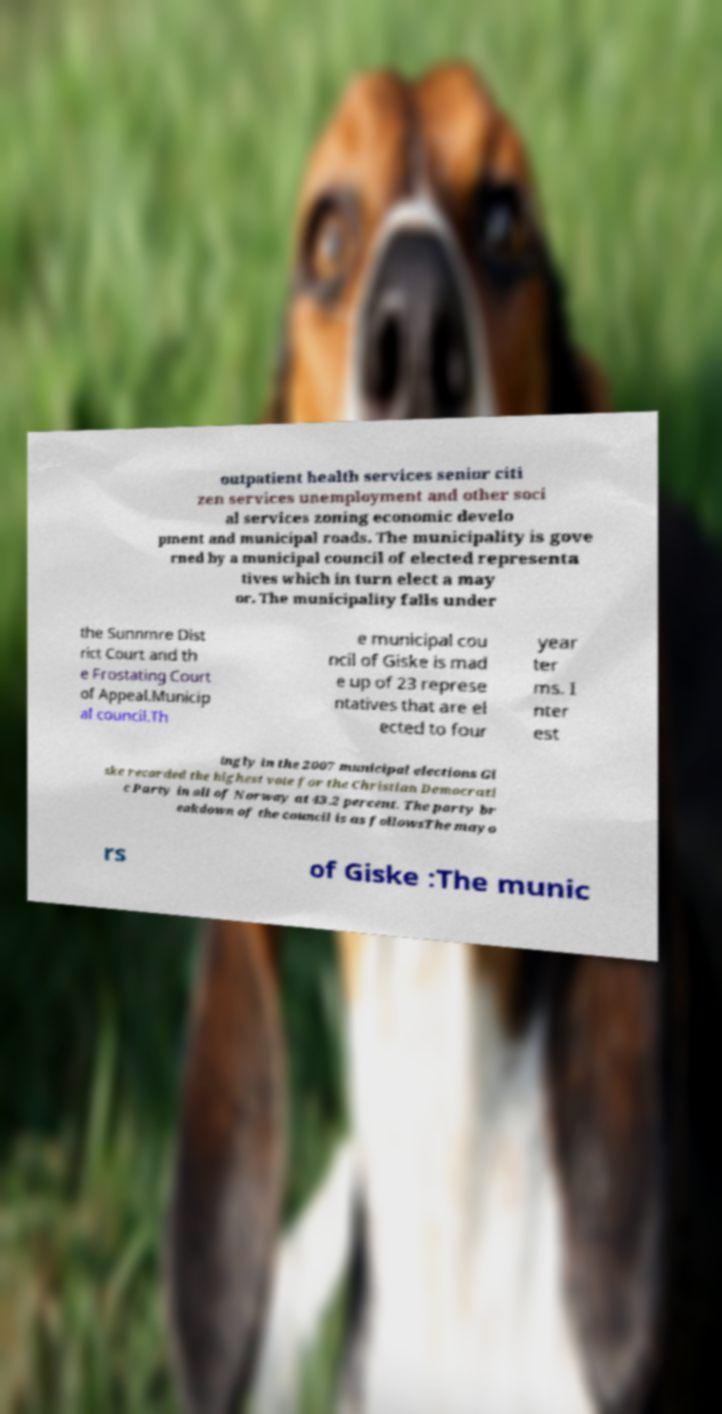Can you read and provide the text displayed in the image?This photo seems to have some interesting text. Can you extract and type it out for me? outpatient health services senior citi zen services unemployment and other soci al services zoning economic develo pment and municipal roads. The municipality is gove rned by a municipal council of elected representa tives which in turn elect a may or. The municipality falls under the Sunnmre Dist rict Court and th e Frostating Court of Appeal.Municip al council.Th e municipal cou ncil of Giske is mad e up of 23 represe ntatives that are el ected to four year ter ms. I nter est ingly in the 2007 municipal elections Gi ske recorded the highest vote for the Christian Democrati c Party in all of Norway at 43.2 percent. The party br eakdown of the council is as followsThe mayo rs of Giske :The munic 